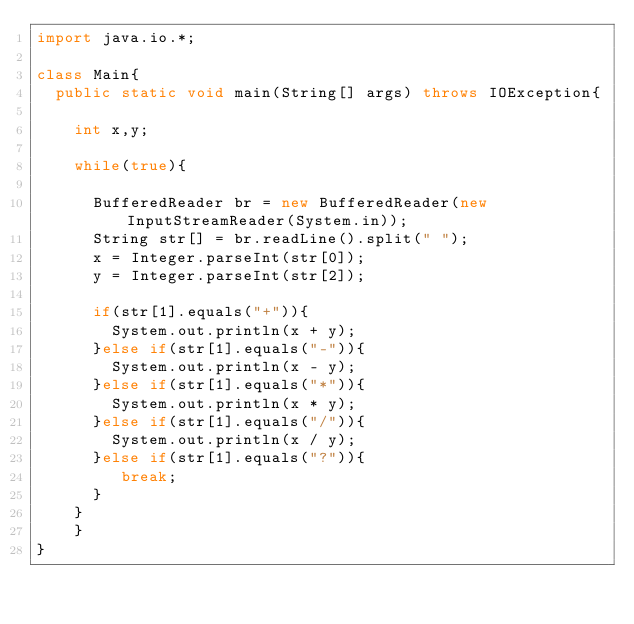<code> <loc_0><loc_0><loc_500><loc_500><_Java_>import java.io.*;
  
class Main{
	public static void main(String[] args) throws IOException{

		int x,y;

		while(true){

			BufferedReader br = new BufferedReader(new InputStreamReader(System.in));
			String str[] = br.readLine().split(" ");
			x = Integer.parseInt(str[0]);
			y = Integer.parseInt(str[2]);
			
			if(str[1].equals("+")){
			 	System.out.println(x + y);
			}else if(str[1].equals("-")){
				System.out.println(x - y);
			}else if(str[1].equals("*")){
			 	System.out.println(x * y);
			}else if(str[1].equals("/")){
				System.out.println(x / y);
			}else if(str[1].equals("?")){
				 break;
			}
		}
  	}
}</code> 